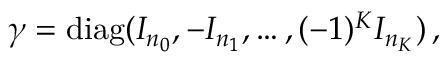<formula> <loc_0><loc_0><loc_500><loc_500>\begin{array} { r } { \gamma = d i a g ( I _ { n _ { 0 } } , - I _ { n _ { 1 } } , \dots , ( - 1 ) ^ { K } I _ { n _ { K } } ) \, , } \end{array}</formula> 